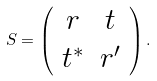<formula> <loc_0><loc_0><loc_500><loc_500>S = \left ( \begin{array} { c c } r & t \\ t ^ { * } & r ^ { \prime } \end{array} \right ) .</formula> 